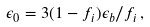Convert formula to latex. <formula><loc_0><loc_0><loc_500><loc_500>\epsilon _ { 0 } = 3 ( 1 - f _ { i } ) \epsilon _ { b } / f _ { i } \, ,</formula> 